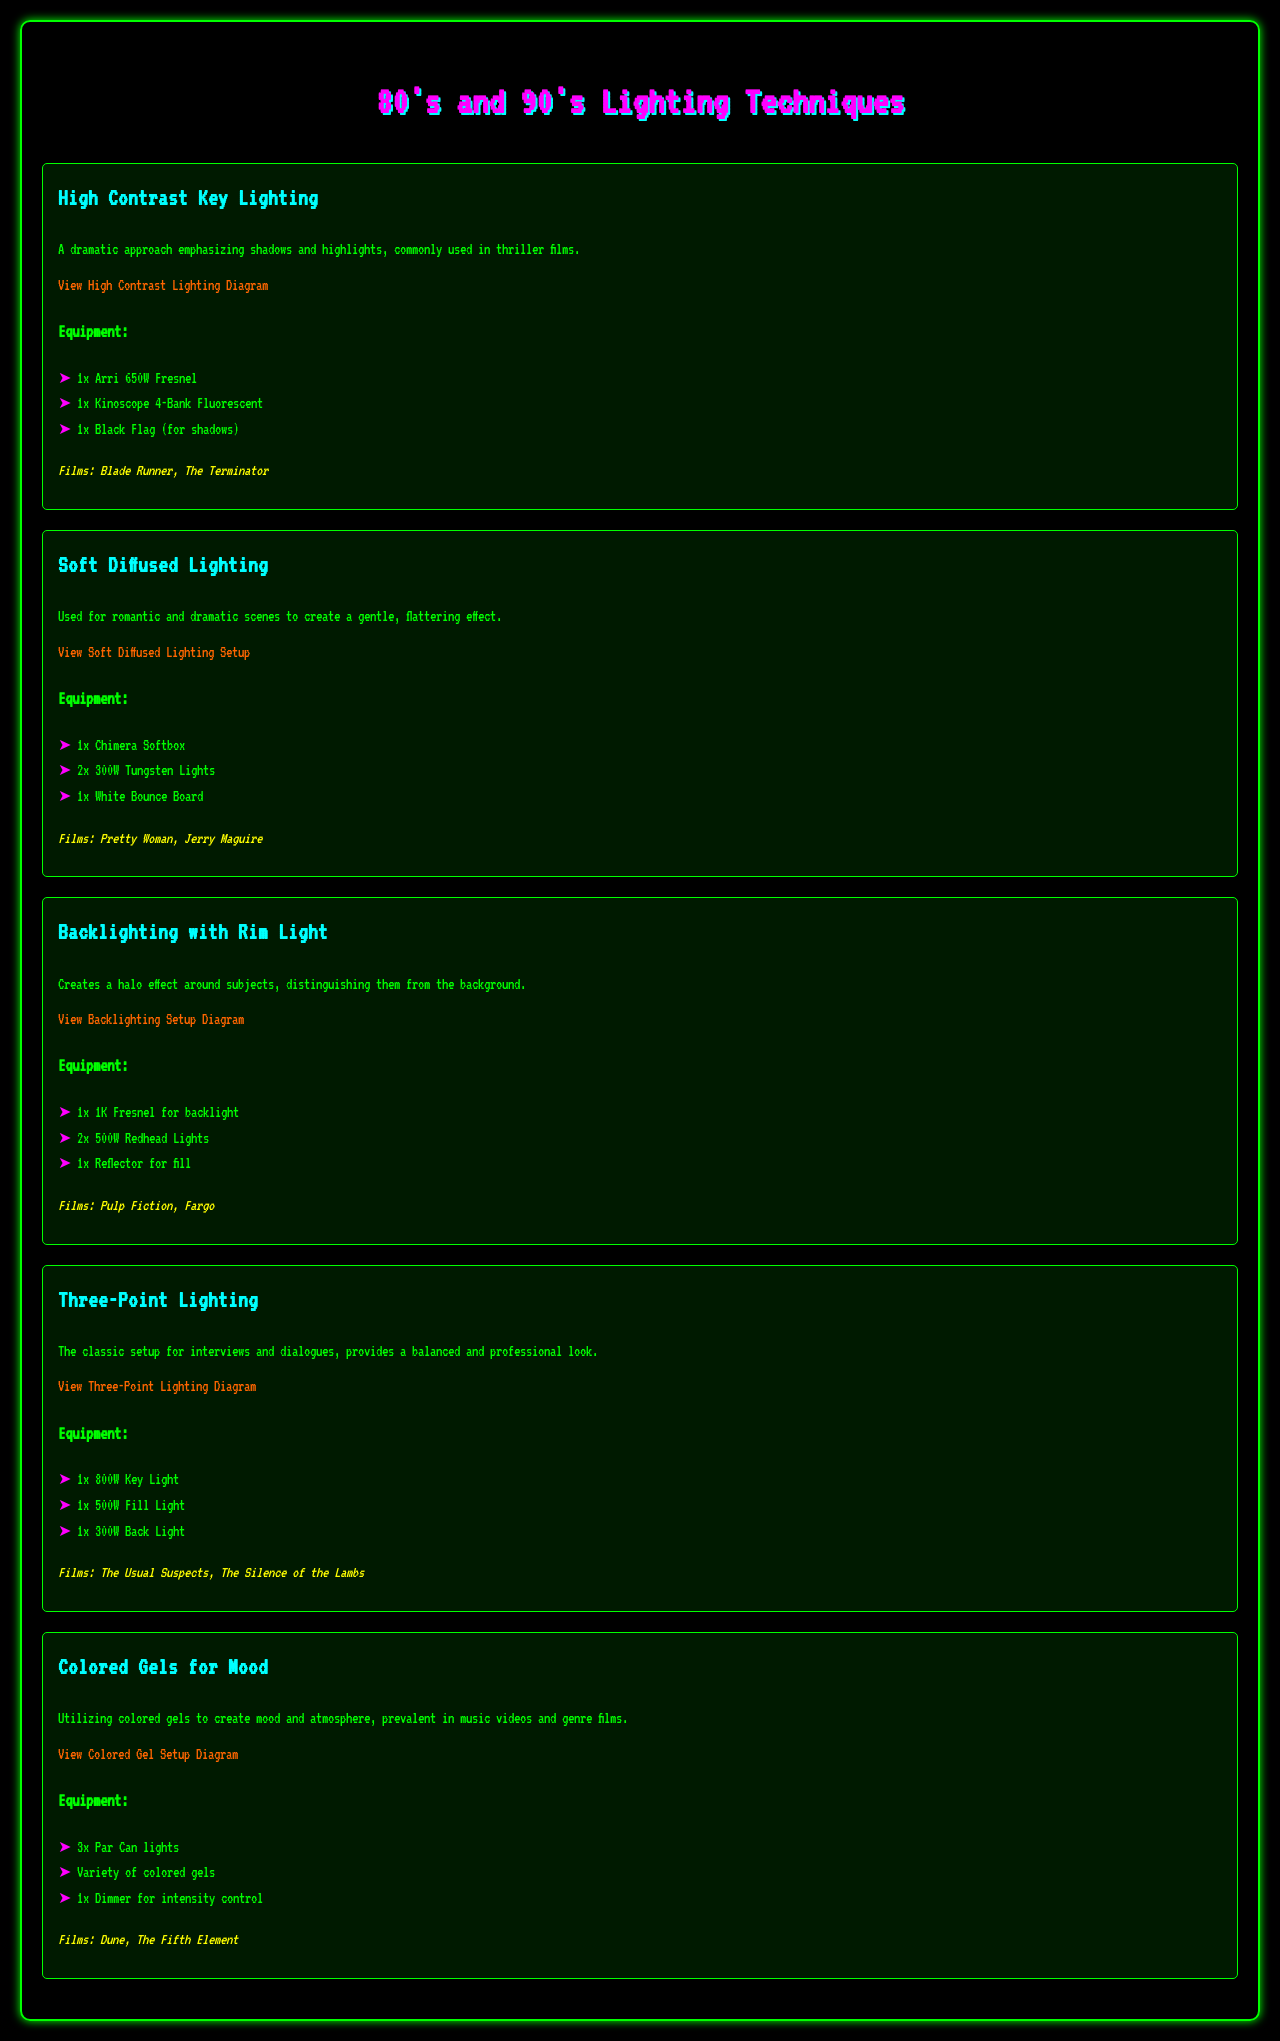What is the first lighting technique listed in the document? The first lighting technique mentioned in the document is "High Contrast Key Lighting."
Answer: High Contrast Key Lighting How many lights are used in the Soft Diffused Lighting setup? The Soft Diffused Lighting setup uses three lights according to the equipment list.
Answer: 3 Which film is associated with Backlighting with Rim Light? The film "Pulp Fiction" is specifically noted under the Backlighting with Rim Light technique.
Answer: Pulp Fiction What type of light is used as the key light in the Three-Point Lighting setup? The equipment list specifies "800W Key Light" as the key light used in this setup.
Answer: 800W Key Light What are colored gels primarily used for in the document? Colored gels are utilized to create mood and atmosphere, as indicated in the description.
Answer: Mood and atmosphere How many equipment items are listed for the Colored Gels for Mood technique? The Colored Gels for Mood technique lists three equipment items in the document.
Answer: 3 What color are the highlighted elements in the headings? The headings feature a cyan color for emphasis as stated in the style section.
Answer: Cyan Which film is mentioned alongside the High Contrast Key Lighting technique? "Blade Runner" is one of the films mentioned with the High Contrast Key Lighting technique.
Answer: Blade Runner 